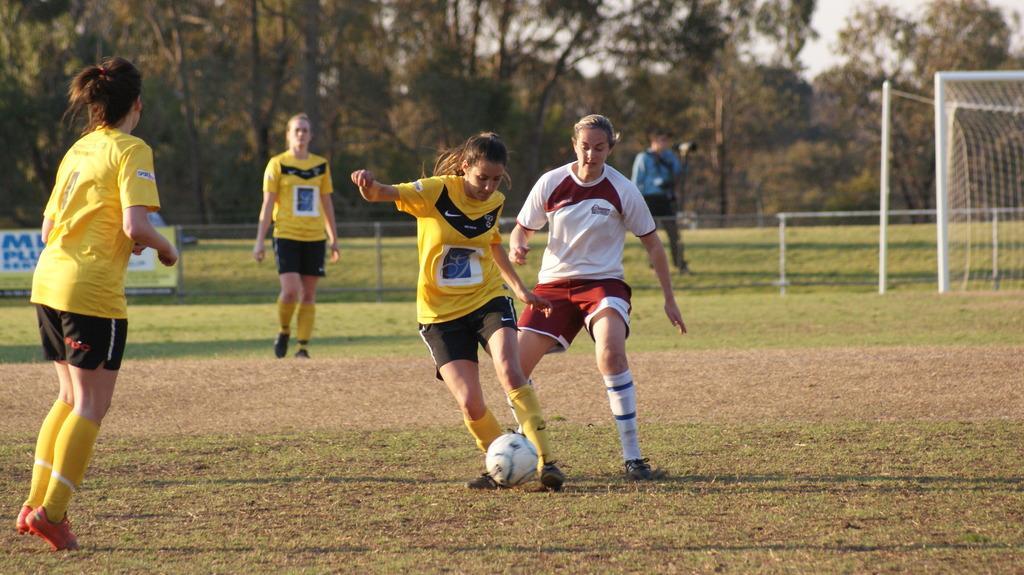Describe this image in one or two sentences. This is a picture of a field where we have four sports people and a ball. 